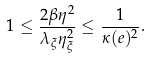Convert formula to latex. <formula><loc_0><loc_0><loc_500><loc_500>1 \leq \frac { 2 \beta \eta ^ { 2 } } { \lambda _ { \xi } \eta _ { \xi } ^ { 2 } } \leq \frac { 1 } { \kappa ( e ) ^ { 2 } } .</formula> 